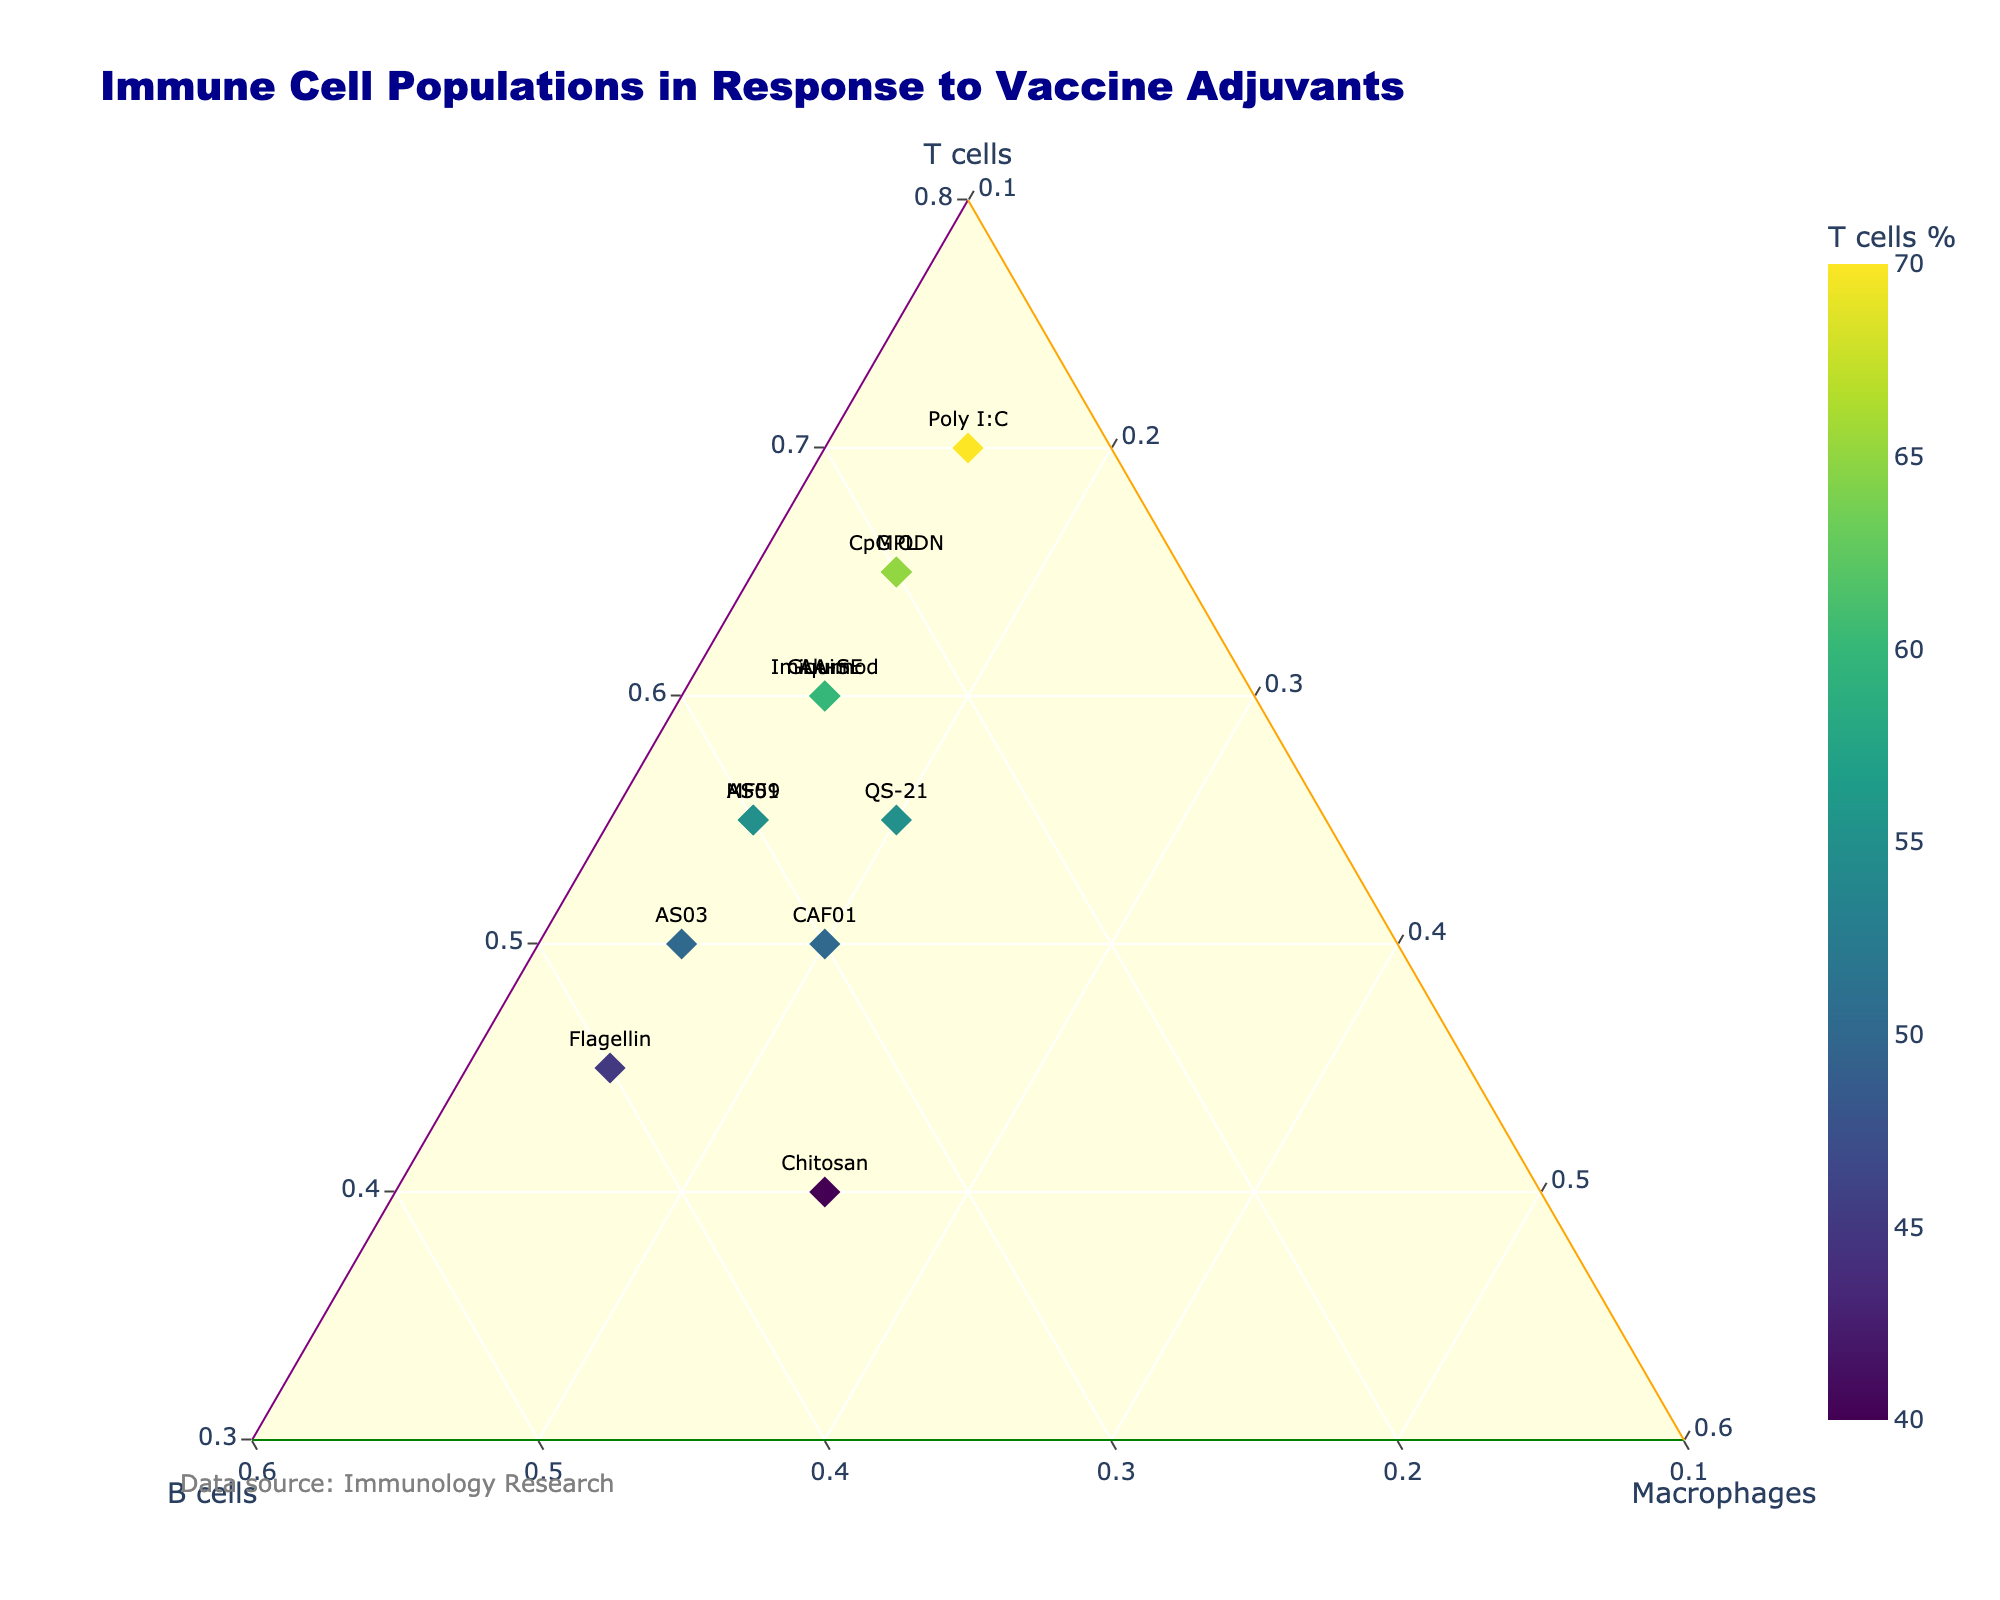What's the title of the plot? The title is usually placed at the top of the plot. In this figure, it reads "Immune Cell Populations in Response to Vaccine Adjuvants".
Answer: Immune Cell Populations in Response to Vaccine Adjuvants How are the colors of the markers determined? Each marker represents a different adjuvant, and the color of the marker corresponds to the percentage of T cells, with a color scale shown on the right.
Answer: By T cells percentage Which adjuvant has the highest percentage of B cells? To find this, locate the adjuvant marker that is closest to the B cells axis (in the upper right). This marker belongs to "Flagellin".
Answer: Flagellin Which axis represents T cells? The plot has three axes labeled, corresponding to T cells (left axis), B cells (right axis), and Macrophages (bottom axis). The T cells axis is the left one.
Answer: Left axis How many data points have a higher percentage of T cells than B cells? Looking at the markers, only "Chitosan" and "Flagellin" do not have higher percentages of T cells than B cells. There are 11 markers on the ternary plot, so 9 adjuvants have higher T cell percentages.
Answer: 9 Which adjuvant shows the highest percentage in the Macrophages axis? All markers are measured for Macrophages, and they are summarized in the dataset. According to the data, "Chitosan" has the highest percentage of Macrophages (25%).
Answer: Chitosan What is common among all adjuvants in terms of Macrophages percentage? Reviewing the dataset shows that all adjuvants except "Chitosan" have 15% Macrophages.
Answer: All except Chitosan have 15% Macrophages Which adjuvants have exactly the same immune cell compositions? By examining the points on the plot, you can conclude that "Alum", "MPL", "Imiquimod", and "GLA-SE" show the same coordinates, confirming equal percentages.
Answer: Alum, MPL, Imiquimod, GLA-SE What is the range of T cell percentages across different adjuvants? The T cell percentages range from the minimum at "Chitosan" with 40% T cells up to the maximum at "Poly I:C" with 70%.
Answer: 40% to 70% 